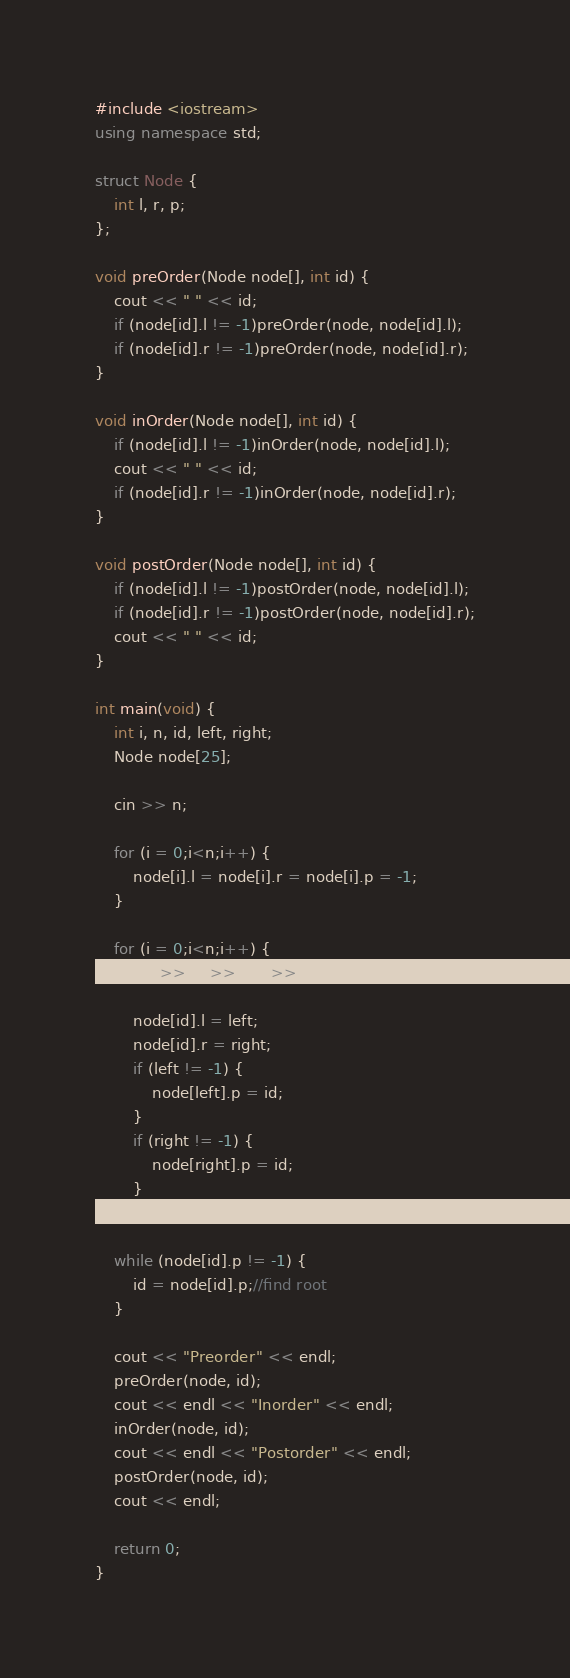Convert code to text. <code><loc_0><loc_0><loc_500><loc_500><_C++_>#include <iostream>
using namespace std;

struct Node {
	int l, r, p;
};

void preOrder(Node node[], int id) {
	cout << " " << id;
	if (node[id].l != -1)preOrder(node, node[id].l);
	if (node[id].r != -1)preOrder(node, node[id].r);
}

void inOrder(Node node[], int id) {
	if (node[id].l != -1)inOrder(node, node[id].l);
	cout << " " << id;
	if (node[id].r != -1)inOrder(node, node[id].r);
}

void postOrder(Node node[], int id) {
	if (node[id].l != -1)postOrder(node, node[id].l);
	if (node[id].r != -1)postOrder(node, node[id].r);
	cout << " " << id;
}

int main(void) {
	int i, n, id, left, right;
	Node node[25];

	cin >> n;

	for (i = 0;i<n;i++) {
		node[i].l = node[i].r = node[i].p = -1;
	}

	for (i = 0;i<n;i++) {
		cin >> id >> left >> right;

		node[id].l = left;
		node[id].r = right;
		if (left != -1) {
			node[left].p = id;
		}
		if (right != -1) {
			node[right].p = id;
		}
	}

	while (node[id].p != -1) {
		id = node[id].p;//find root
	}

	cout << "Preorder" << endl;
	preOrder(node, id);
	cout << endl << "Inorder" << endl;
	inOrder(node, id);
	cout << endl << "Postorder" << endl;
	postOrder(node, id);
	cout << endl;

	return 0;
}

</code> 